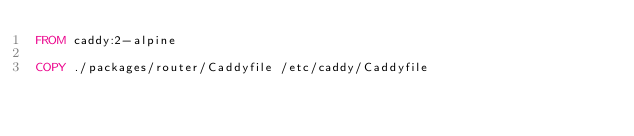Convert code to text. <code><loc_0><loc_0><loc_500><loc_500><_Dockerfile_>FROM caddy:2-alpine

COPY ./packages/router/Caddyfile /etc/caddy/Caddyfile
</code> 